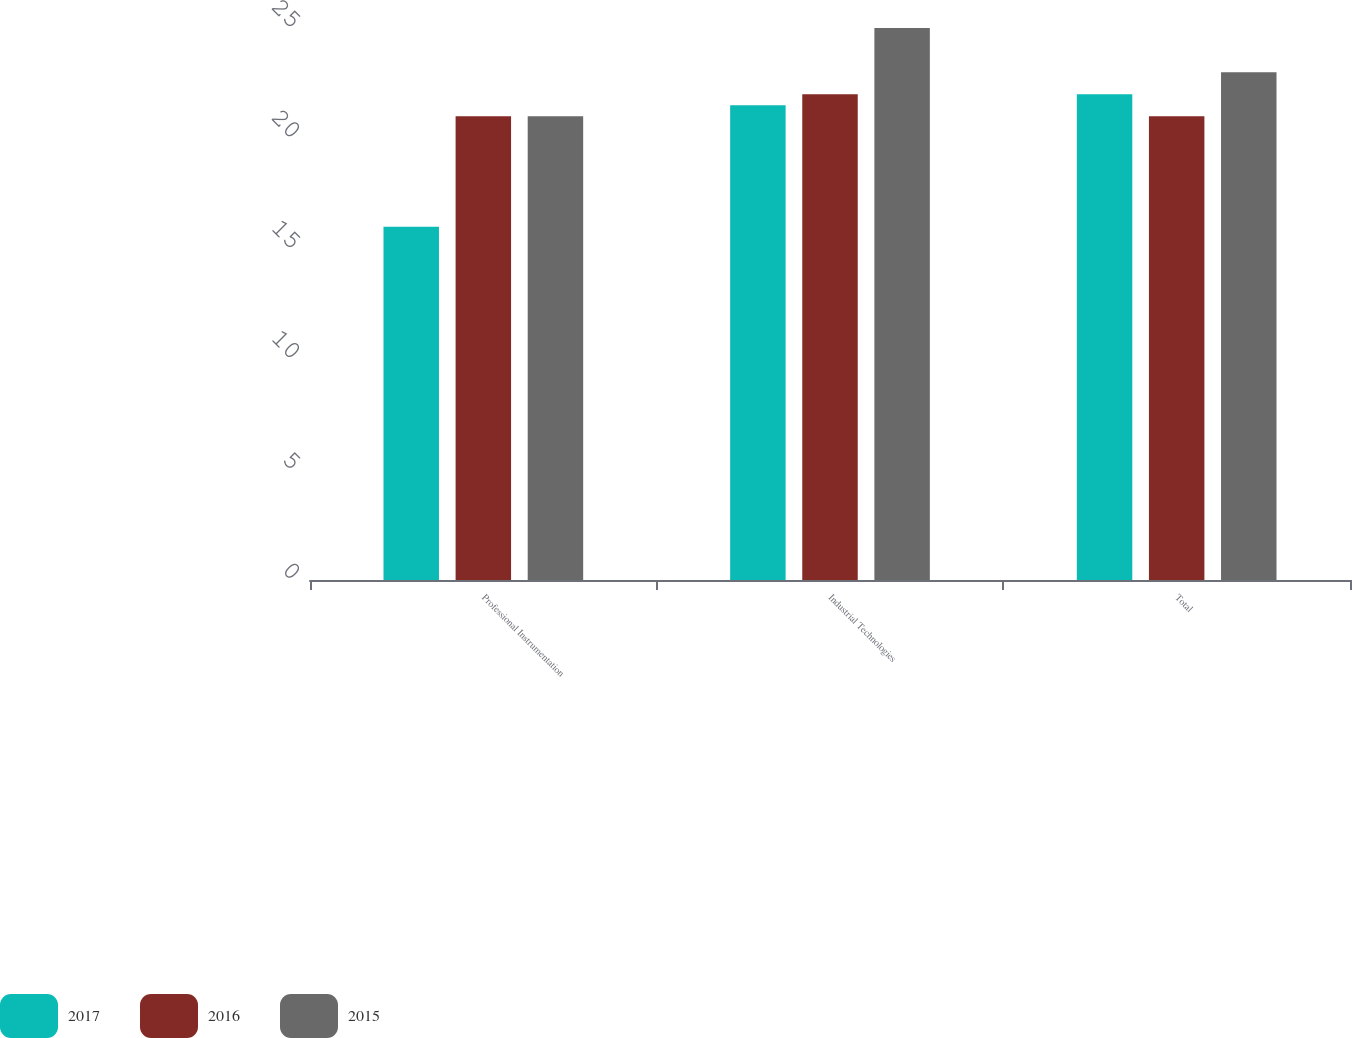Convert chart. <chart><loc_0><loc_0><loc_500><loc_500><stacked_bar_chart><ecel><fcel>Professional Instrumentation<fcel>Industrial Technologies<fcel>Total<nl><fcel>2017<fcel>16<fcel>21.5<fcel>22<nl><fcel>2016<fcel>21<fcel>22<fcel>21<nl><fcel>2015<fcel>21<fcel>25<fcel>23<nl></chart> 